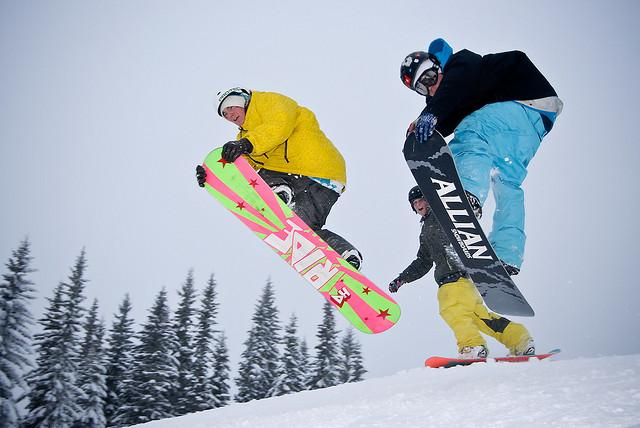What have these children likely practiced? Please explain your reasoning. skiing. These kids seem to be experts at snow sports. 